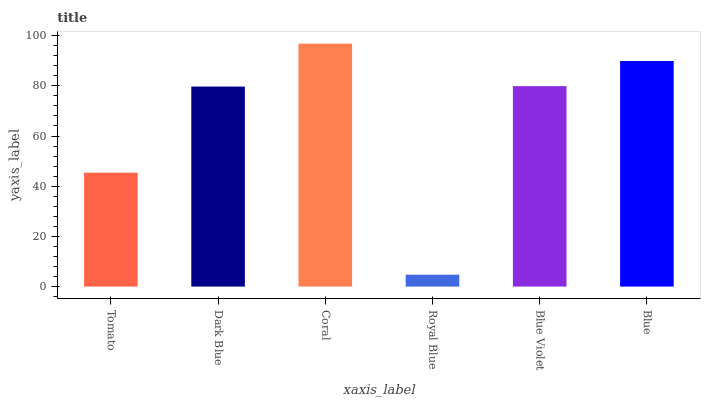Is Royal Blue the minimum?
Answer yes or no. Yes. Is Coral the maximum?
Answer yes or no. Yes. Is Dark Blue the minimum?
Answer yes or no. No. Is Dark Blue the maximum?
Answer yes or no. No. Is Dark Blue greater than Tomato?
Answer yes or no. Yes. Is Tomato less than Dark Blue?
Answer yes or no. Yes. Is Tomato greater than Dark Blue?
Answer yes or no. No. Is Dark Blue less than Tomato?
Answer yes or no. No. Is Blue Violet the high median?
Answer yes or no. Yes. Is Dark Blue the low median?
Answer yes or no. Yes. Is Tomato the high median?
Answer yes or no. No. Is Royal Blue the low median?
Answer yes or no. No. 